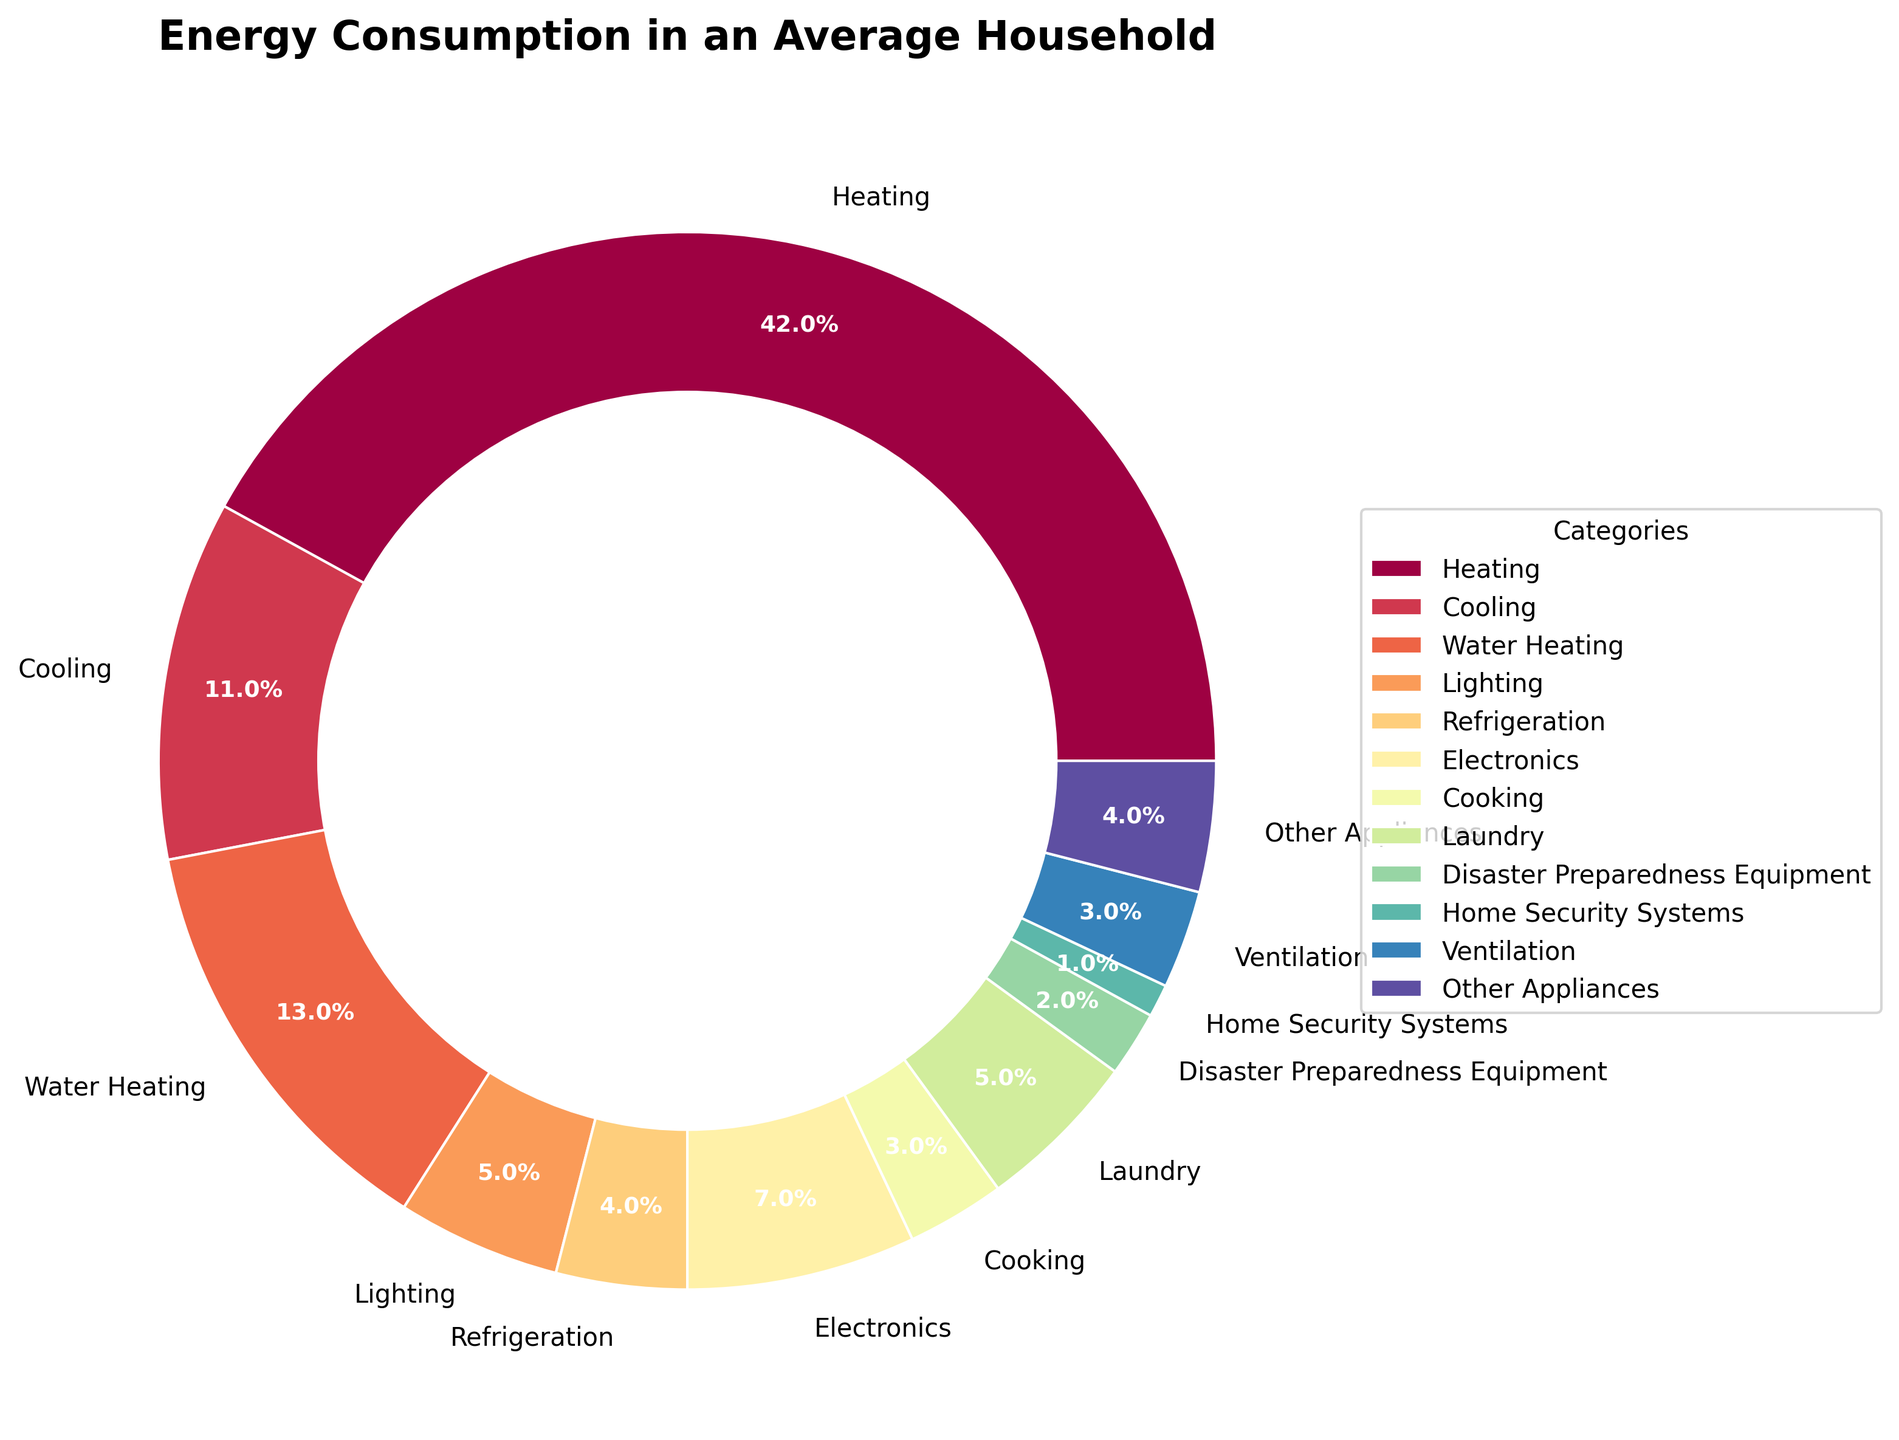What percentage of energy consumption is used by Heating and Cooling combined? To find the combined percentage of energy consumption for Heating and Cooling, simply add the percentages of both categories: Heating (42%) + Cooling (11%) = 53%.
Answer: 53% Which category uses more energy: Lighting or Laundry? Compare the percentages of the two categories: Lighting (5%) and Laundry (5%). Since both percentages are equal, neither category uses more energy.
Answer: Equal What is the difference in energy consumption between Water Heating and Refrigeration? Subtract the percentage of Refrigeration from the percentage of Water Heating: Water Heating (13%) - Refrigeration (4%) = 9%.
Answer: 9% Is the energy consumption for Electronics greater than the sum of Cooking and Home Security Systems? First, calculate the sum of Cooking and Home Security Systems: Cooking (3%) + Home Security Systems (1%) = 4%. Then, compare it to Electronics (7%). Since 7% (Electronics) is greater than 4% (Cooking + Home Security Systems), the answer is yes.
Answer: Yes How does the energy consumption for Disaster Preparedness Equipment compare to Ventilation? Disaster Preparedness Equipment consumes 2% of the energy, while Ventilation consumes 3%. Since 2% is less than 3%, Disaster Preparedness Equipment uses less energy than Ventilation.
Answer: Less What is the average energy consumption for Water Heating, Lighting, and Refrigeration? Add the percentages of these three categories and divide by the number of categories: (Water Heating 13% + Lighting 5% + Refrigeration 4%) / 3 = 22% / 3 ≈ 7.33%.
Answer: 7.33% Which category uses the least amount of energy? Identify the category with the lowest percentage: Home Security Systems, with 1%.
Answer: Home Security Systems What percentage of energy consumption is attributed to categories other than Heating? First, add up all the percentages of the non-Heating categories: Cooling (11%) + Water Heating (13%) + Lighting (5%) + Refrigeration (4%) + Electronics (7%) + Cooking (3%) + Laundry (5%) + Disaster Preparedness Equipment (2%) + Home Security Systems (1%) + Ventilation (3%) + Other Appliances (4%) = 58%. This means that 100% - 42% (Heating) = 58%.
Answer: 58% If Ventilation and Cooking were combined into a single category, what would be its percentage, and would it rank higher than Water Heating? Combine the two percentages: Ventilation (3%) + Cooking (3%) = 6%. Compare this to Water Heating (13%). Since 6% is less than 13%, the combined category would not rank higher than Water Heating.
Answer: 6%, No 